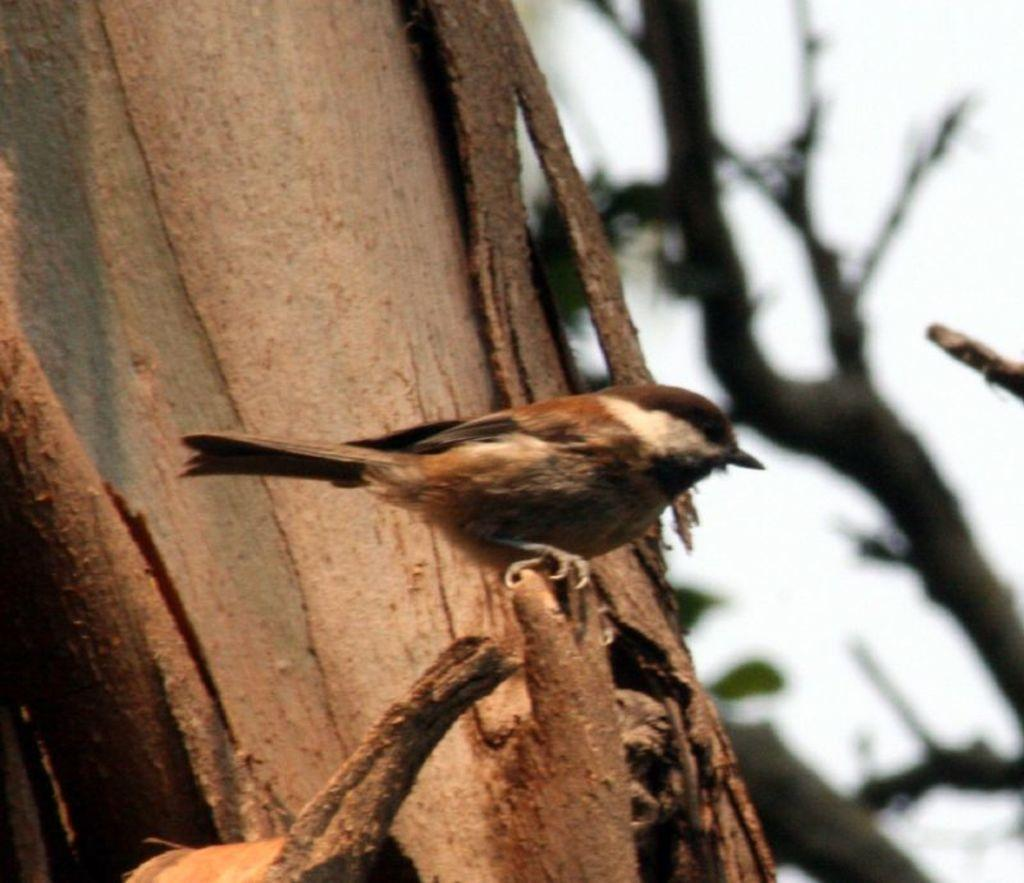What type of animal is in the image? There is a bird in the image. Where is the bird located in the image? The bird is on a branch. What else can be seen in the background of the image? There are branches and the sky visible in the background of the image. How many passengers are visible in the image? There are no passengers present in the image. What type of wood can be seen in the image? There is no wood present in the image; it features a bird on a branch. Can you tell me how many roots are visible in the image? There are no roots visible in the image. 